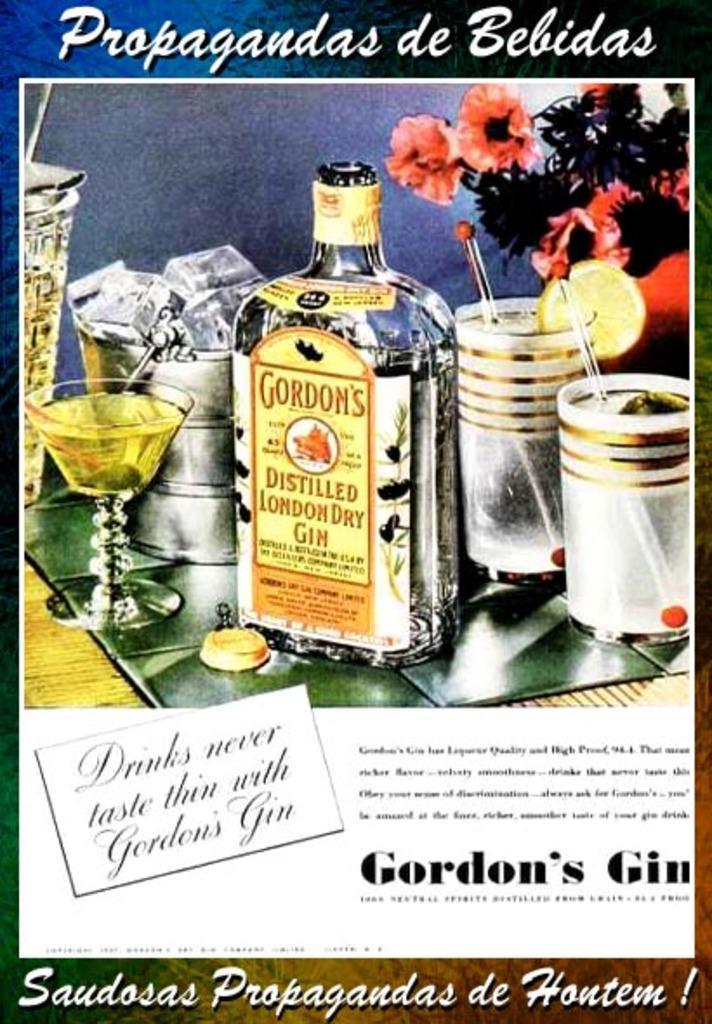Please provide a concise description of this image. In this image I can see a picture of a bottle and few glasses. I can also see a flower. 